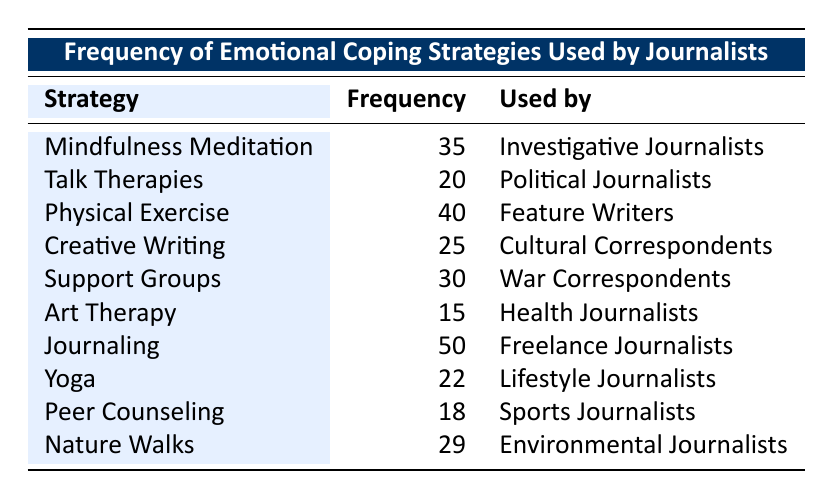What is the frequency of Journaling as an emotional coping strategy? The table shows that Journaling has a frequency of 50.
Answer: 50 Which emotional coping strategy is used most frequently by journalists? By examining the frequency values, Journaling with a frequency of 50 is the highest among all strategies.
Answer: Journaling Do Political Journalists use more emotional coping strategies than Health Journalists? Political Journalists use Talk Therapies with a frequency of 20, while Health Journalists use Art Therapy with a frequency of 15. Thus, Political Journalists use more strategies.
Answer: Yes What is the sum of the frequencies of Mindfulness Meditation and Support Groups? The frequency for Mindfulness Meditation is 35 and for Support Groups is 30. Adding these gives 35 + 30 = 65.
Answer: 65 Is the frequency of Physical Exercise greater than the average frequency of the provided strategies? The frequencies are: 35, 20, 40, 25, 30, 15, 50, 22, 18, 29. The sum is  35 + 20 + 40 + 25 + 30 + 15 + 50 + 22 + 18 + 29 =  269. There are 10 strategies, so the average is 269 / 10 = 26.9. Physical Exercise has a frequency of 40, which is higher than the average.
Answer: Yes Which two emotional coping strategies have the lowest frequencies? The two lowest frequencies in the table are for Art Therapy (15) and Peer Counseling (18).
Answer: Art Therapy and Peer Counseling How many journalists use Nature Walks compared to those who use Talk Therapies? Nature Walks are used by 29 journalists, while Talk Therapies are used by 20. Therefore, more journalists use Nature Walks.
Answer: Nature Walks (29) > Talk Therapies (20) What is the difference in frequency between the emotional coping strategies used by Feature Writers and War Correspondents? Feature Writers use Physical Exercise (40) and War Correspondents use Support Groups (30). The difference is calculated as 40 - 30 = 10.
Answer: 10 Which group of journalists reported using Creative Writing? The table indicates that Creative Writing is used by Cultural Correspondents.
Answer: Cultural Correspondents 